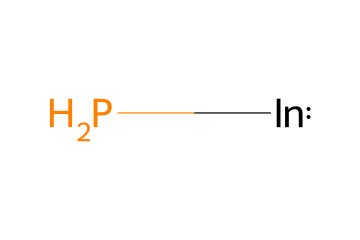What is the main component of this quantum dot? The SMILES representation indicates the presence of indium (In) and phosphorus (P), which together comprise indium phosphide.
Answer: indium phosphide How many different types of atoms are present in the chemical? The chemical composition consists of two types of atoms: indium (In) and phosphorus (P).
Answer: two What is the significance of the indium atom in the structure? Indium is a group III element and contributes to the semiconductor properties of the quantum dots, making them useful in various applications including biomedical imaging.
Answer: semiconductor What is the molecular formula derived from the SMILES representation? The SMILES representation corresponds to the formula InP, which is derived by recognizing the elements present: one indium atom and one phosphorus atom.
Answer: InP Why is indium phosphide considered less toxic for biomedical imaging? Indium phosphide quantum dots are considered less toxic due to the absence of heavy metals commonly found in other quantum dots, which makes them safer for biological applications.
Answer: less toxic What type of applications can indium phosphide quantum dots be used for? Indium phosphide quantum dots are primarily used for non-toxic biomedical imaging and other optical applications due to their favorable electronic and optical properties.
Answer: biomedical imaging How does the atomic arrangement in indium phosphide affect its optical properties? The arrangement of indium and phosphorus in the crystal lattice determines the bandgap and electronic structure, which in turn influences the optical properties such as light absorption and emission.
Answer: optical properties 